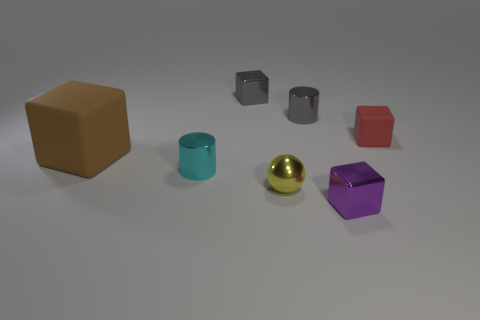Subtract all red blocks. How many blocks are left? 3 Add 2 small green cubes. How many objects exist? 9 Subtract all purple blocks. How many blocks are left? 3 Subtract 1 balls. How many balls are left? 0 Subtract all balls. How many objects are left? 6 Add 1 yellow metal objects. How many yellow metal objects are left? 2 Add 6 red cubes. How many red cubes exist? 7 Subtract 0 red spheres. How many objects are left? 7 Subtract all cyan balls. Subtract all green blocks. How many balls are left? 1 Subtract all blue cubes. How many cyan cylinders are left? 1 